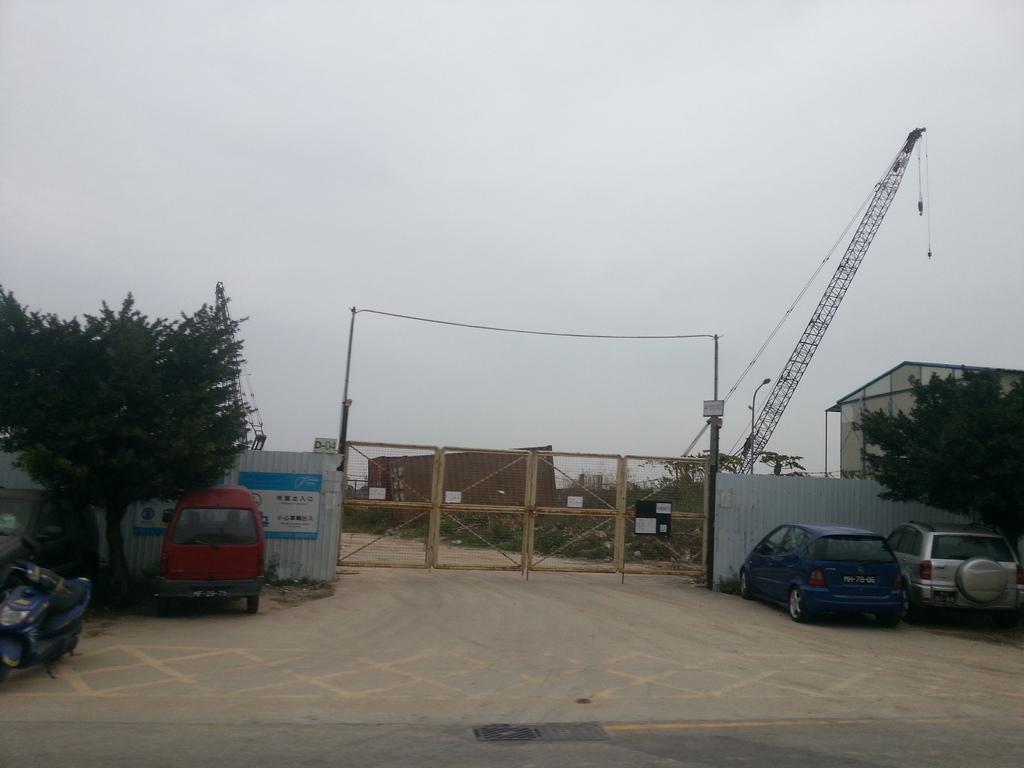Could you give a brief overview of what you see in this image? In this picture we can see few trees and vehicles in front of the gate, in the background we can see a building, container and a crane. 